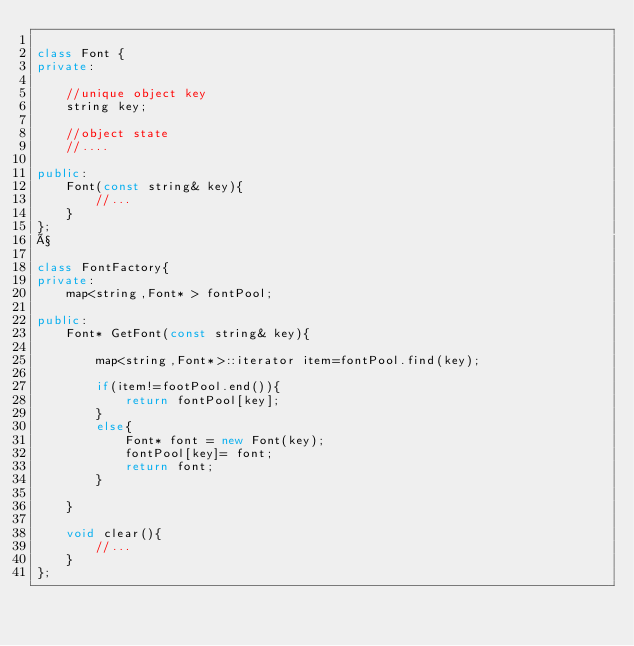Convert code to text. <code><loc_0><loc_0><loc_500><loc_500><_C++_>
class Font {
private:

    //unique object key
    string key;
    
    //object state
    //....
    
public:
    Font(const string& key){
        //...
    }
};
ß

class FontFactory{
private:
    map<string,Font* > fontPool;
    
public:
    Font* GetFont(const string& key){

        map<string,Font*>::iterator item=fontPool.find(key);
        
        if(item!=footPool.end()){
            return fontPool[key];
        }
        else{
            Font* font = new Font(key);
            fontPool[key]= font;
            return font;
        }

    }
    
    void clear(){
        //...
    }
};</code> 